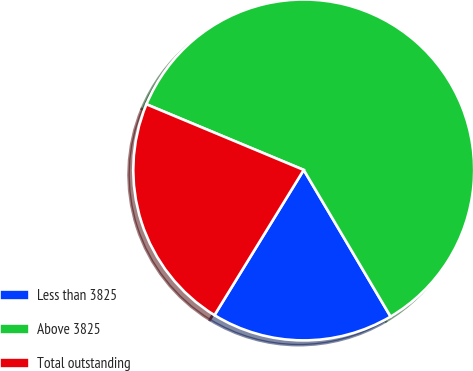Convert chart. <chart><loc_0><loc_0><loc_500><loc_500><pie_chart><fcel>Less than 3825<fcel>Above 3825<fcel>Total outstanding<nl><fcel>17.28%<fcel>60.19%<fcel>22.52%<nl></chart> 